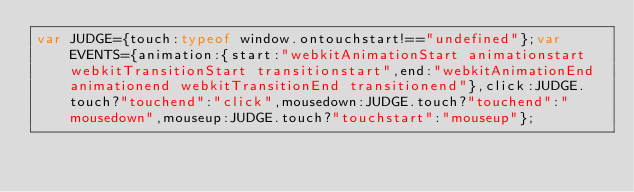Convert code to text. <code><loc_0><loc_0><loc_500><loc_500><_JavaScript_>var JUDGE={touch:typeof window.ontouchstart!=="undefined"};var EVENTS={animation:{start:"webkitAnimationStart animationstart webkitTransitionStart transitionstart",end:"webkitAnimationEnd animationend webkitTransitionEnd transitionend"},click:JUDGE.touch?"touchend":"click",mousedown:JUDGE.touch?"touchend":"mousedown",mouseup:JUDGE.touch?"touchstart":"mouseup"};</code> 